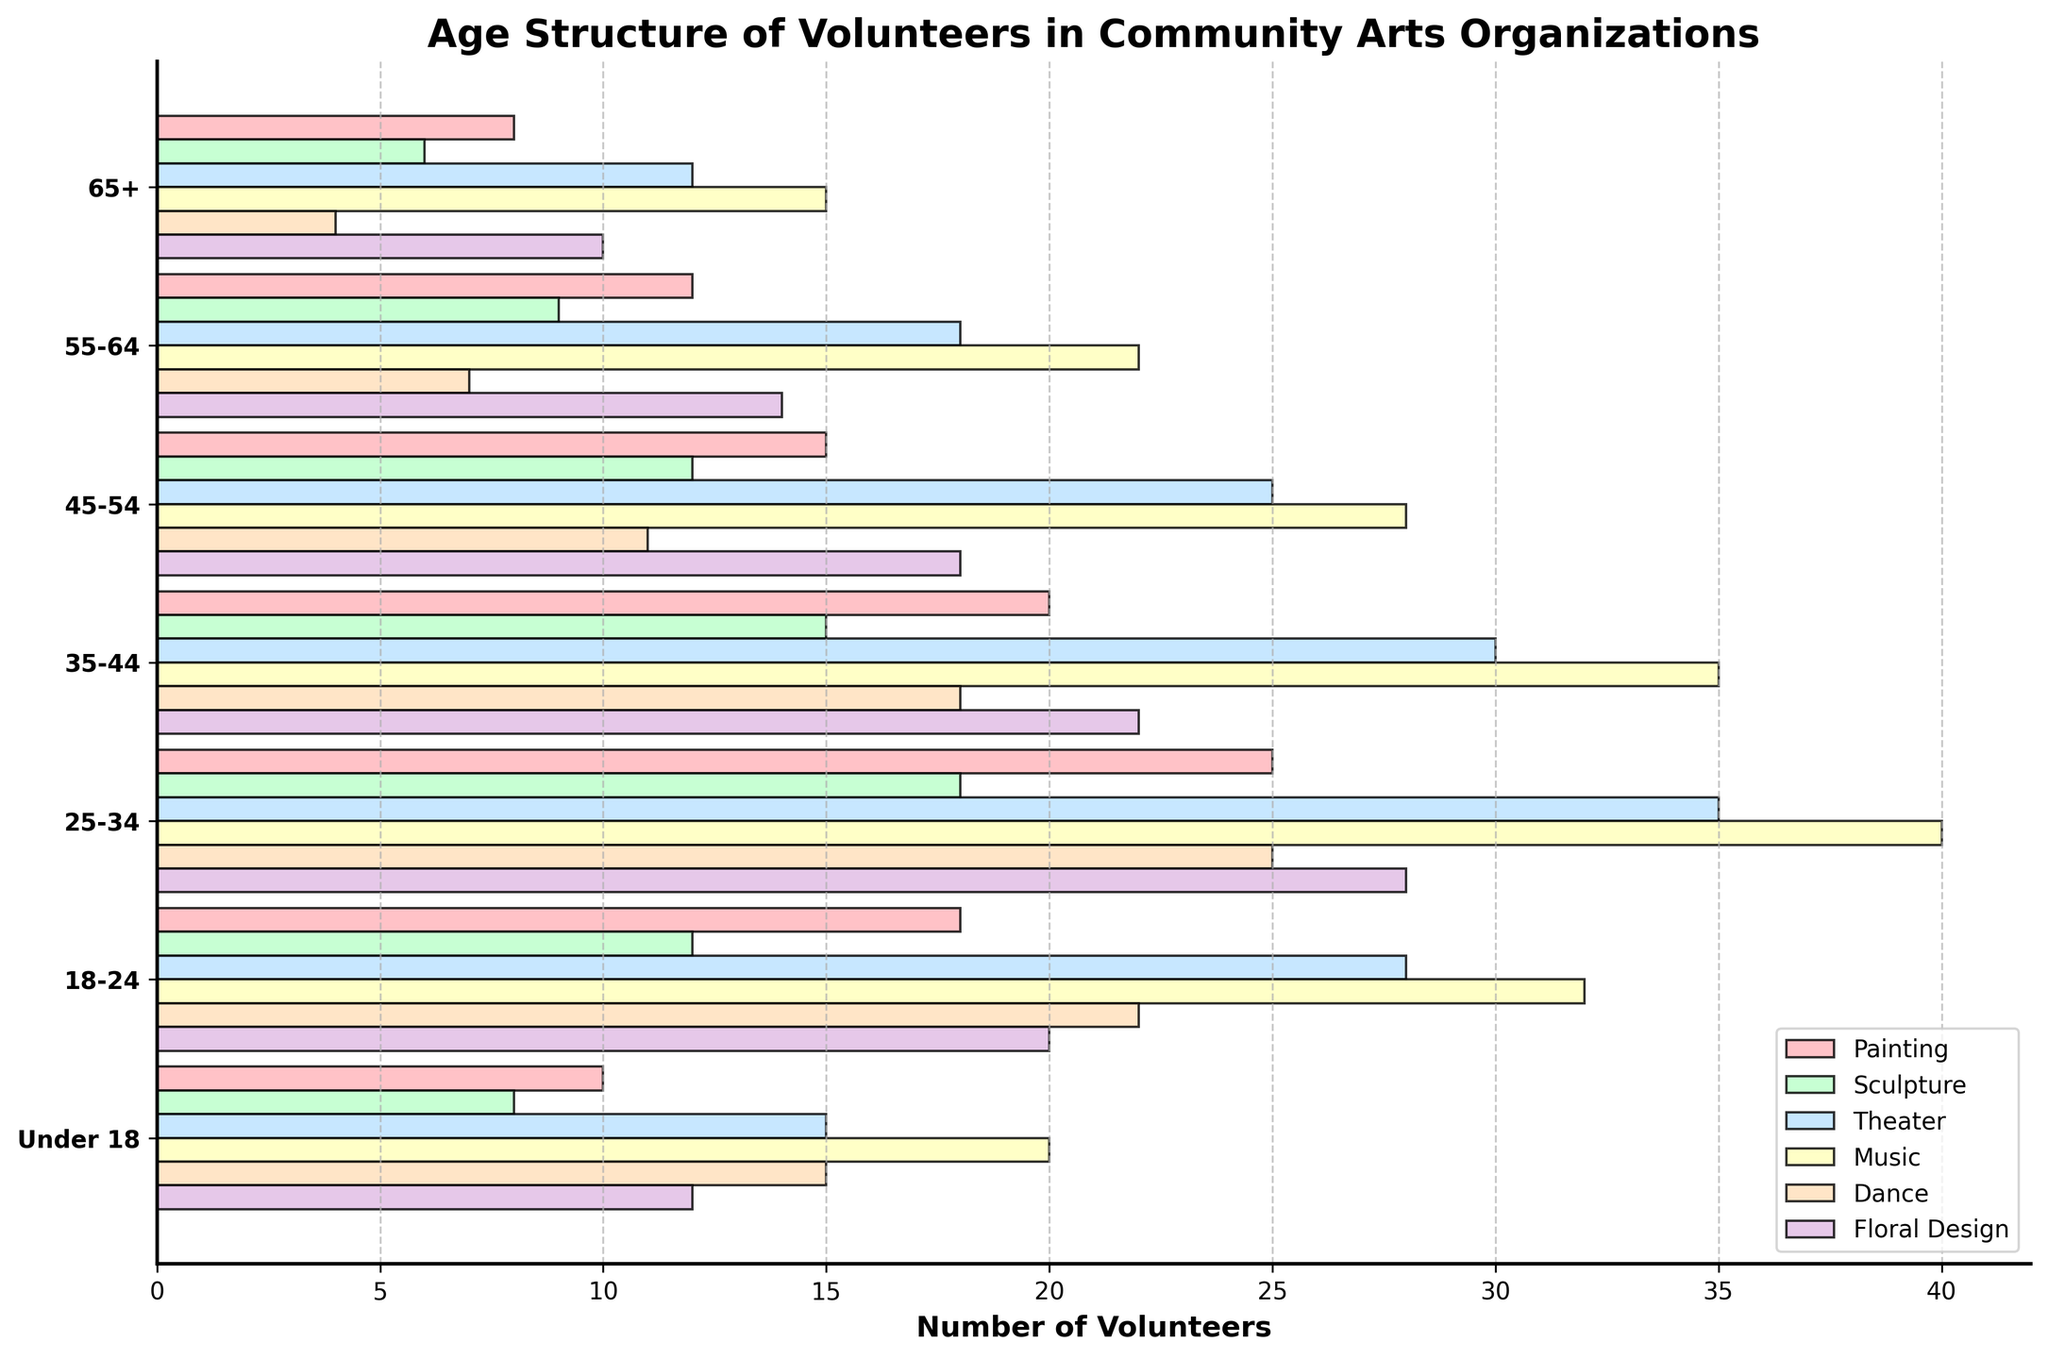What is the title of the figure? The title of the figure can be found at the top of the plot. It is the main heading that describes what the data visualization is about.
Answer: Age Structure of Volunteers in Community Arts Organizations Which age group has the most volunteers in Painting? Look for the horizontal bar that extends the furthest in the "Painting" section and identify the age group associated with it.
Answer: 25-34 How many Sculpture volunteers are there in the 55-64 age group? Locate the horizontal bar for the "Sculpture" discipline in the "55-64" age group and read the corresponding value.
Answer: 9 What is the total number of Dance volunteers across all age groups? Sum the values for "Dance" across all age groups: 4 + 7 + 11 + 18 + 25 + 22 + 15. The total is 102.
Answer: 102 In which age group is there the smallest difference between Theater and Music volunteers? Examine the bars for each age group and find the age group where the difference between the values for "Theater" and "Music" is the smallest. For example, in the 55-64 age group, the difference is
Answer: 65+ Which artistic discipline has the third lowest number of volunteers in the Under 18 age group? Compare the values for each artistic discipline in the "Under 18" age group and identify the third smallest value.
Answer: Floral Design How many more Theater volunteers are there than Sculpture volunteers in the 45-54 age group? Subtract the number of Sculpture volunteers from the number of Theater volunteers in the 45-54 age group: 25 - 12 = 13.
Answer: 13 What is the average number of volunteers in Music for the 35-44 and 45-54 age groups? Add the number of volunteers in Music for 35-44 and 45-54 age groups, then divide by 2: (35 + 28) / 2 = 31.5.
Answer: 31.5 Which age group has the least number of volunteers in Dance? Find the age group with the shortest bar in the "Dance" section to identify the one with the least number of volunteers.
Answer: 65+ 